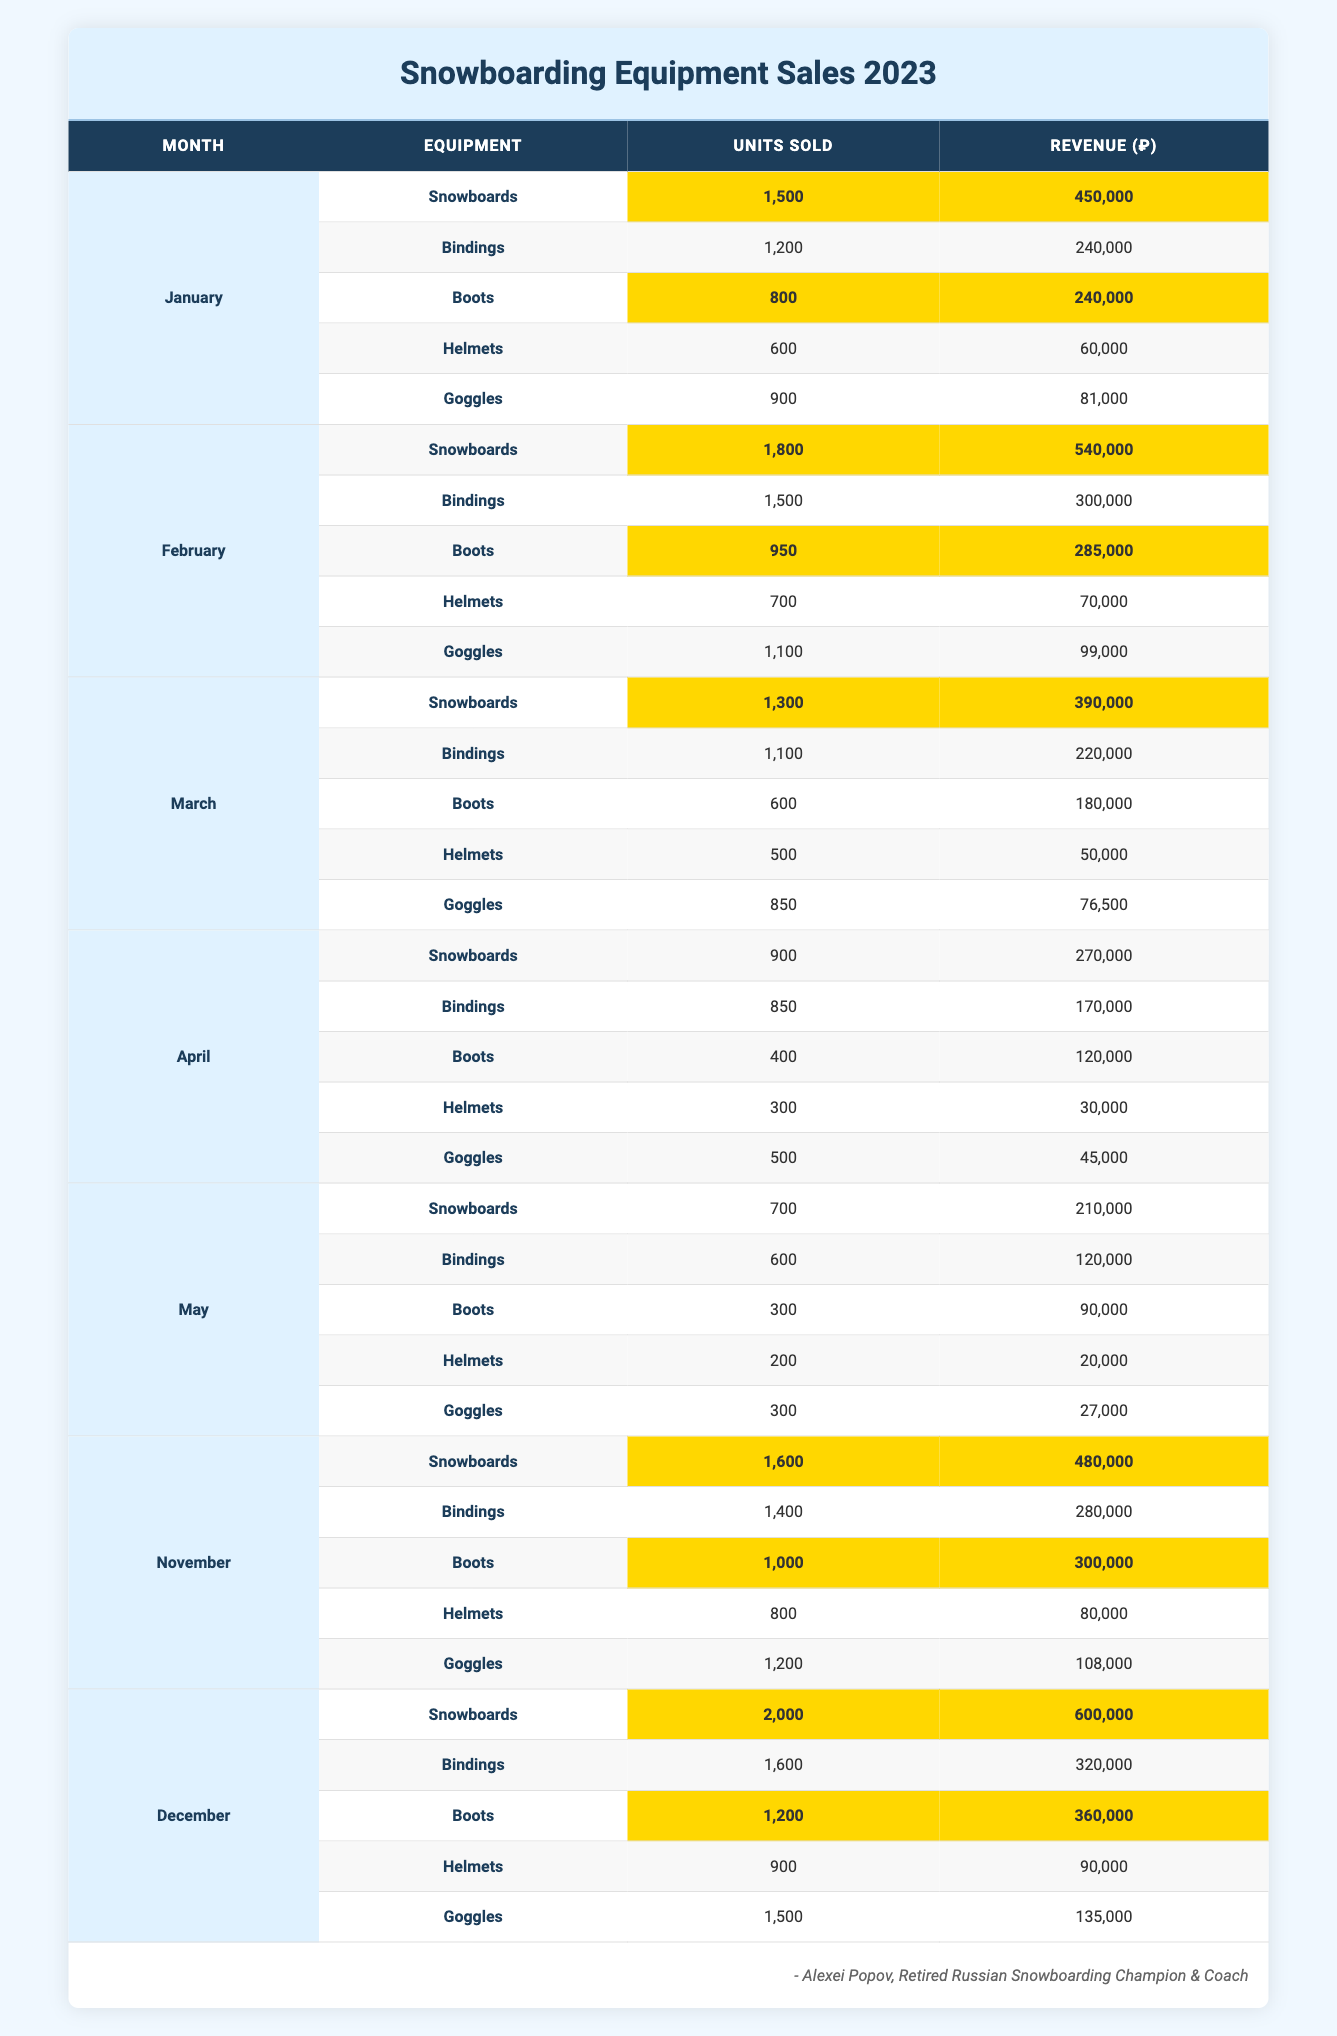What was the total revenue from snowboards in December? The revenue from snowboards in December is recorded as 600,000.
Answer: 600,000 Which month had the highest sales of boots? The month with the highest sales of boots is December, with 1,200 units sold.
Answer: December What is the total number of bindings sold across all months? The total units sold for bindings are 1,200 (January) + 1,500 (February) + 1,100 (March) + 850 (April) + 600 (May) + 1,400 (November) + 1,600 (December) = 8,300.
Answer: 8,300 Did the sales of snowboards exceed 1,800 units in February? Yes, the sales of snowboards in February were 1,800 units, which is not exceeding but equal to 1,800.
Answer: No What was the average revenue from boots sold for the first three months? The revenue for boots in the first three months is 240,000 (January) + 285,000 (February) + 180,000 (March) = 705,000. The average divides this total by 3, yielding 705,000 / 3 = 235,000.
Answer: 235,000 Which month had the lowest sales of snowboards? April had the lowest sales of snowboards at 900 units.
Answer: April How much more revenue did snowboards generate than goggles in November? For snowboards in November, revenue is 480,000 and for goggles, it is 108,000. Calculating the difference: 480,000 - 108,000 = 372,000.
Answer: 372,000 Are the sales of helmets consistent across all months with more than 500 units sold? No, the number of helmets sold varied greatly, with only January, February, and November exceeding 500 units sold.
Answer: No What percentage of the total sales for boots in December does the revenue represent compared to January? The revenue for boots in December is 360,000 and in January is 240,000. The percentage is (360,000 / 240,000) * 100 = 150%.
Answer: 150% How many total units of snowboarding equipment were sold in November across all categories? In November, the total units sold of snowboards is 1,600, bindings is 1,400, boots is 1,000, helmets is 800, and goggles is 1,200. Summing these gives 1,600 + 1,400 + 1,000 + 800 + 1,200 = 6,000.
Answer: 6,000 